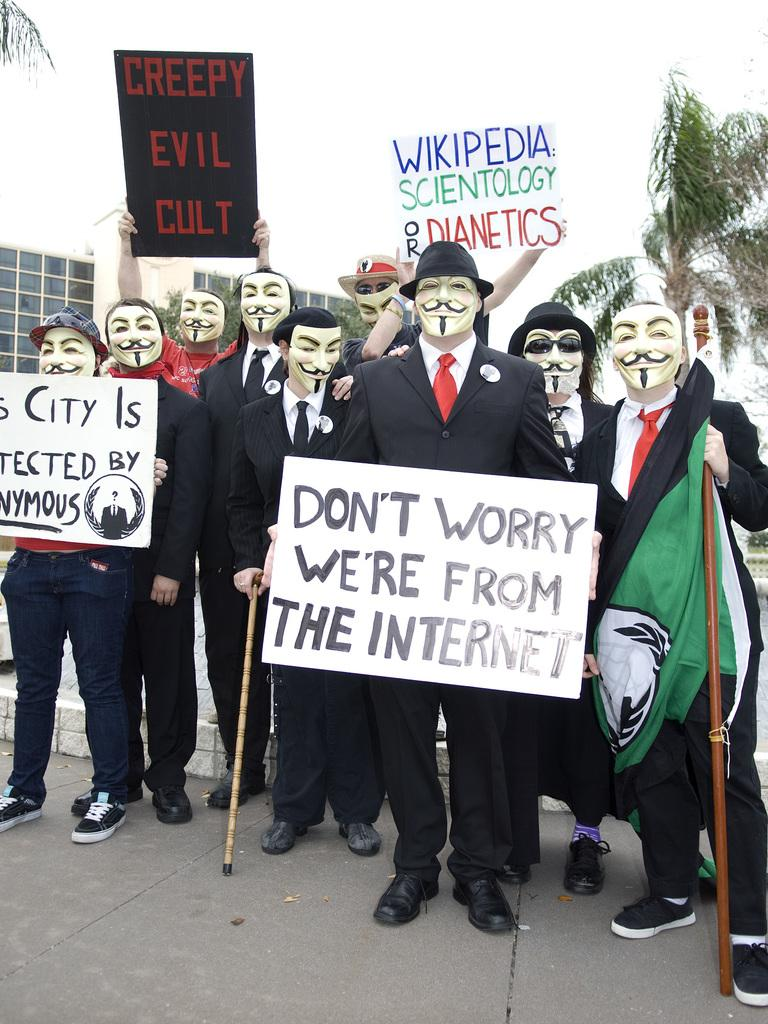<image>
Give a short and clear explanation of the subsequent image. A man in costume holds a sign that reads don't worry we're from the internet. 